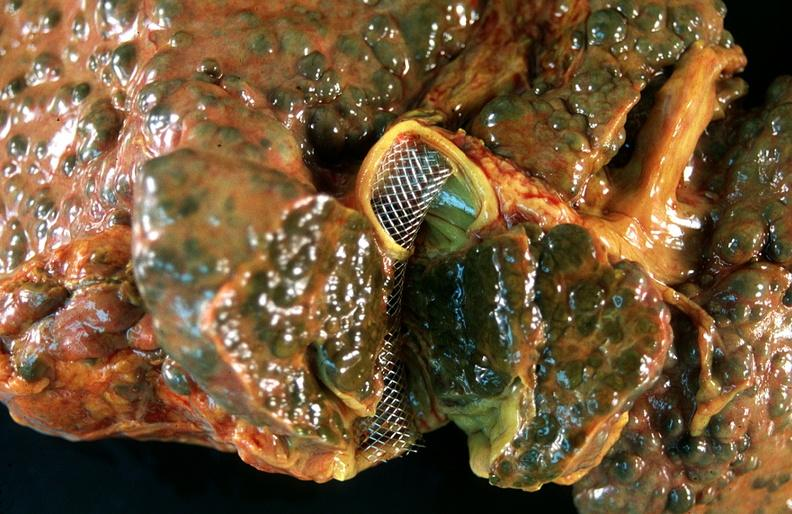s hepatobiliary present?
Answer the question using a single word or phrase. Yes 